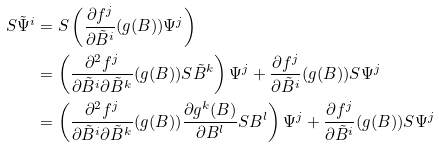<formula> <loc_0><loc_0><loc_500><loc_500>S \tilde { \Psi } ^ { i } & = S \left ( \frac { \partial f ^ { j } } { \partial \tilde { B } ^ { i } } ( g ( B ) ) \Psi ^ { j } \right ) \\ & = \left ( \frac { \partial ^ { 2 } f ^ { j } } { \partial \tilde { B } ^ { i } \partial \tilde { B } ^ { k } } ( g ( B ) ) S \tilde { B } ^ { k } \right ) \Psi ^ { j } + \frac { \partial f ^ { j } } { \partial \tilde { B } ^ { i } } ( g ( B ) ) S \Psi ^ { j } \\ & = \left ( \frac { \partial ^ { 2 } f ^ { j } } { \partial \tilde { B } ^ { i } \partial \tilde { B } ^ { k } } ( g ( B ) ) \frac { \partial g ^ { k } ( B ) } { \partial B ^ { l } } S B ^ { l } \right ) \Psi ^ { j } + \frac { \partial f ^ { j } } { \partial \tilde { B } ^ { i } } ( g ( B ) ) S \Psi ^ { j }</formula> 